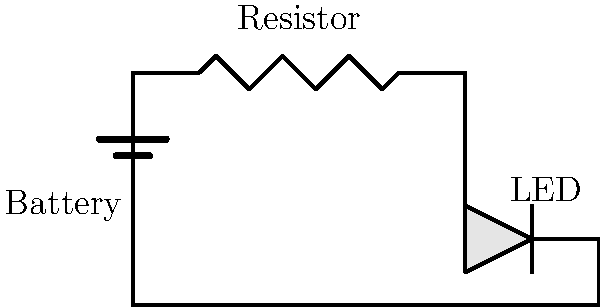In the simple electrical circuit shown above, which component protects the LED from excessive current that could potentially damage it? To understand the role of each component in this circuit, let's break it down step-by-step:

1. The battery provides the electrical energy (voltage) to the circuit.

2. The LED (Light Emitting Diode) is the component that emits light when current passes through it. However, LEDs are sensitive to current and can be easily damaged if too much current flows through them.

3. The resistor is the key component in this circuit for protecting the LED. It serves two important functions:

   a) Current Limitation: The resistor limits the amount of current flowing through the circuit according to Ohm's Law: $I = V/R$, where $I$ is current, $V$ is voltage, and $R$ is resistance.
   
   b) Voltage Drop: The resistor creates a voltage drop across itself, reducing the voltage applied to the LED.

4. By choosing an appropriate resistance value, we can ensure that the current flowing through the LED is within its safe operating range, typically between 10-20 mA for most small LEDs.

5. Without the resistor, the low resistance of the LED would allow a large current to flow, potentially burning out the LED instantly.

Therefore, the resistor is the component that protects the LED from excessive current that could potentially damage it.
Answer: Resistor 